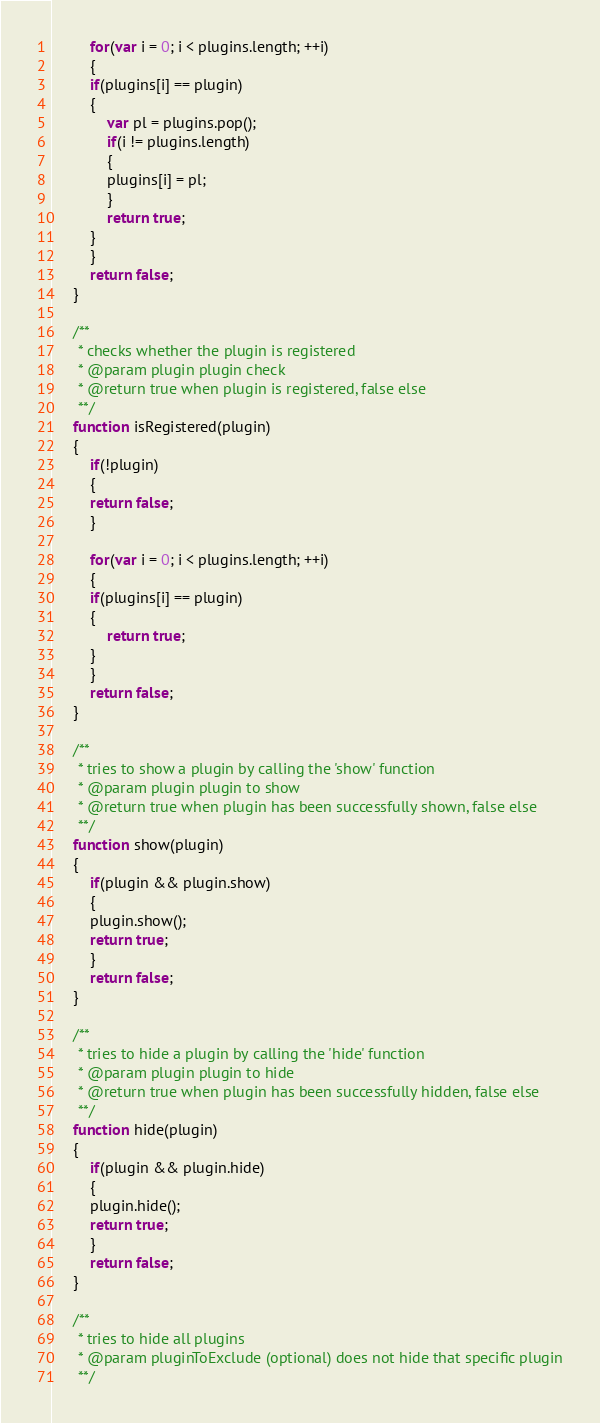Convert code to text. <code><loc_0><loc_0><loc_500><loc_500><_JavaScript_>	     for(var i = 0; i < plugins.length; ++i)
	     {
		 if(plugins[i] == plugin)
		 {
		     var pl = plugins.pop();
		     if(i != plugins.length)
		     {
			 plugins[i] = pl;
		     }
		     return true;
		 }
	     }
	     return false;
	 }

	 /**
	  * checks whether the plugin is registered
	  * @param plugin plugin check
	  * @return true when plugin is registered, false else
	  **/
	 function isRegistered(plugin)
	 {
	     if(!plugin)
	     {
		 return false;
	     }

	     for(var i = 0; i < plugins.length; ++i)
	     {
		 if(plugins[i] == plugin)
		 {
		     return true;
		 }
	     }
	     return false;
	 }

	 /**
	  * tries to show a plugin by calling the 'show' function
	  * @param plugin plugin to show
	  * @return true when plugin has been successfully shown, false else
	  **/
	 function show(plugin)
	 {
	     if(plugin && plugin.show)
	     {
		 plugin.show();
		 return true;
	     }
	     return false;
	 }

	 /**
	  * tries to hide a plugin by calling the 'hide' function
	  * @param plugin plugin to hide
	  * @return true when plugin has been successfully hidden, false else
	  **/
	 function hide(plugin)
	 {
	     if(plugin && plugin.hide)
	     {
		 plugin.hide();
		 return true;
	     }
	     return false;
	 }

	 /**
	  * tries to hide all plugins
	  * @param pluginToExclude (optional) does not hide that specific plugin
	  **/</code> 